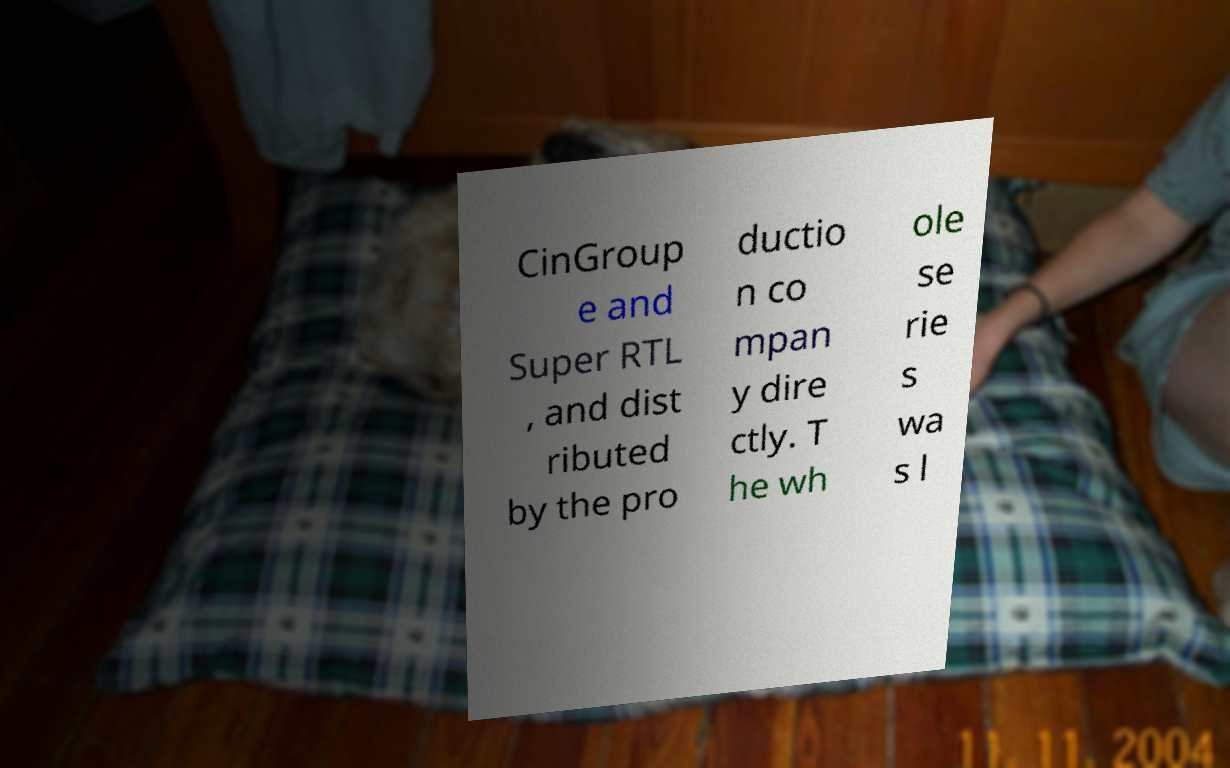Could you assist in decoding the text presented in this image and type it out clearly? CinGroup e and Super RTL , and dist ributed by the pro ductio n co mpan y dire ctly. T he wh ole se rie s wa s l 